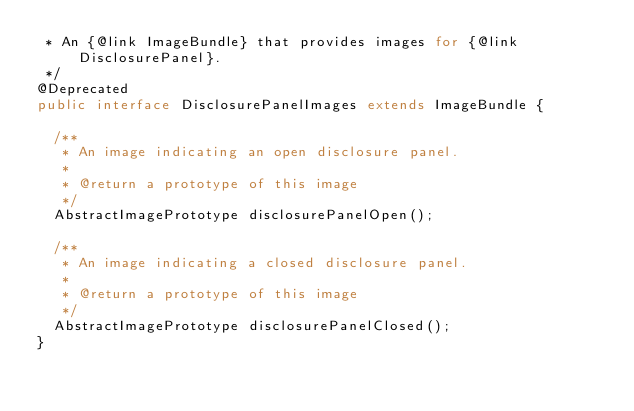<code> <loc_0><loc_0><loc_500><loc_500><_Java_> * An {@link ImageBundle} that provides images for {@link DisclosurePanel}.
 */
@Deprecated
public interface DisclosurePanelImages extends ImageBundle {

  /**
   * An image indicating an open disclosure panel.
   *
   * @return a prototype of this image
   */
  AbstractImagePrototype disclosurePanelOpen();

  /**
   * An image indicating a closed disclosure panel.
   *
   * @return a prototype of this image
   */
  AbstractImagePrototype disclosurePanelClosed();
}
</code> 